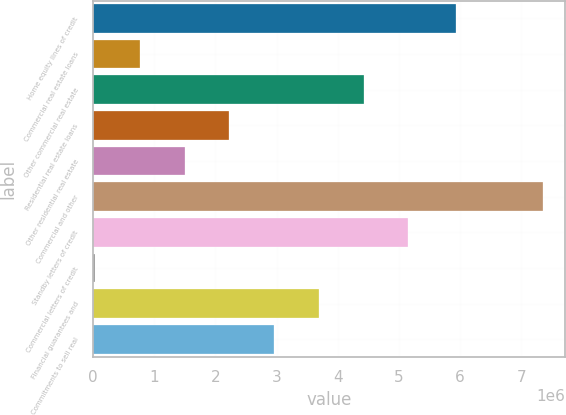Convert chart. <chart><loc_0><loc_0><loc_500><loc_500><bar_chart><fcel>Home equity lines of credit<fcel>Commercial real estate loans<fcel>Other commercial real estate<fcel>Residential real estate loans<fcel>Other residential real estate<fcel>Commercial and other<fcel>Standby letters of credit<fcel>Commercial letters of credit<fcel>Financial guarantees and<fcel>Commitments to sell real<nl><fcel>5.9379e+06<fcel>765374<fcel>4.42172e+06<fcel>2.22791e+06<fcel>1.49664e+06<fcel>7.34679e+06<fcel>5.15298e+06<fcel>34105<fcel>3.69045e+06<fcel>2.95918e+06<nl></chart> 